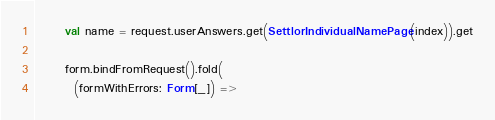<code> <loc_0><loc_0><loc_500><loc_500><_Scala_>
      val name = request.userAnswers.get(SettlorIndividualNamePage(index)).get

      form.bindFromRequest().fold(
        (formWithErrors: Form[_]) =></code> 